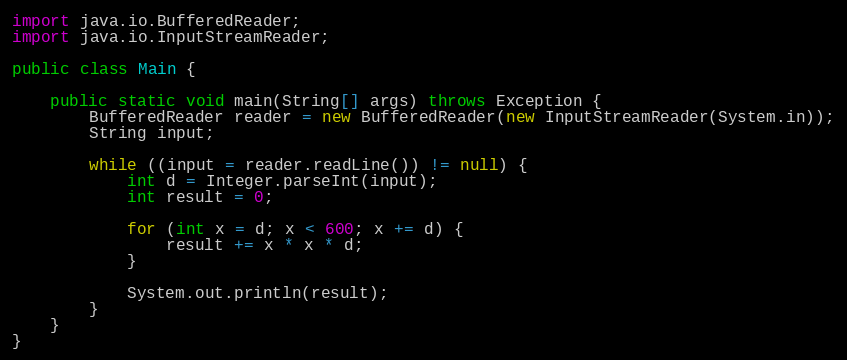Convert code to text. <code><loc_0><loc_0><loc_500><loc_500><_Java_>import java.io.BufferedReader;
import java.io.InputStreamReader;

public class Main {

    public static void main(String[] args) throws Exception {
        BufferedReader reader = new BufferedReader(new InputStreamReader(System.in));
        String input;

        while ((input = reader.readLine()) != null) {
            int d = Integer.parseInt(input);
            int result = 0;

            for (int x = d; x < 600; x += d) {
                result += x * x * d;
            }

            System.out.println(result);
        }
    }
}</code> 